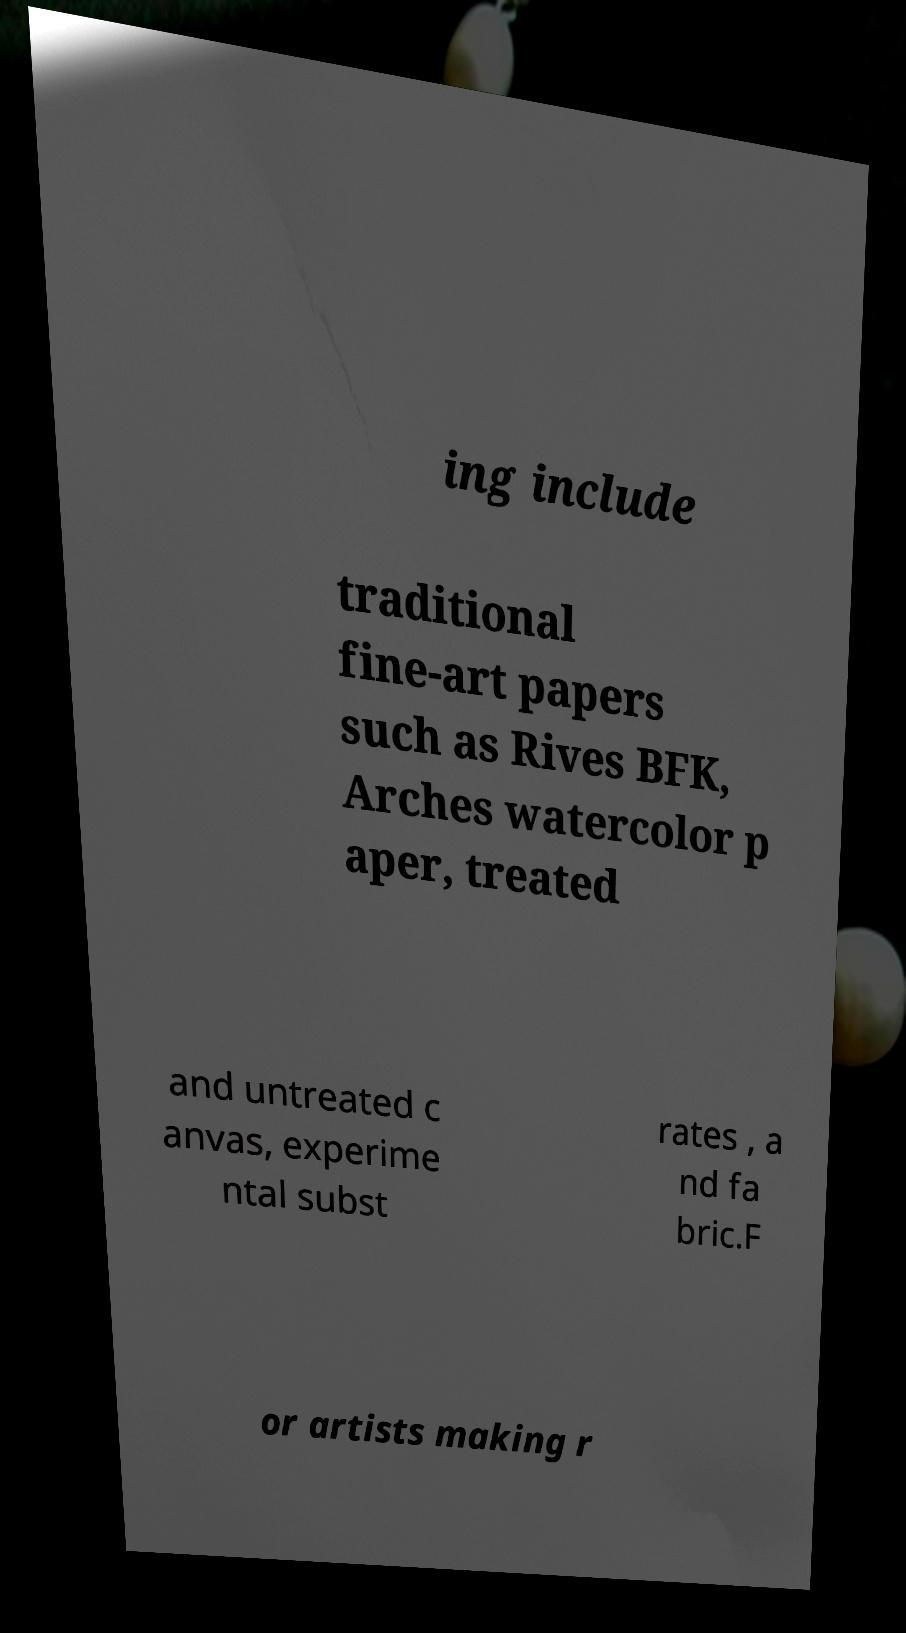Could you assist in decoding the text presented in this image and type it out clearly? ing include traditional fine-art papers such as Rives BFK, Arches watercolor p aper, treated and untreated c anvas, experime ntal subst rates , a nd fa bric.F or artists making r 